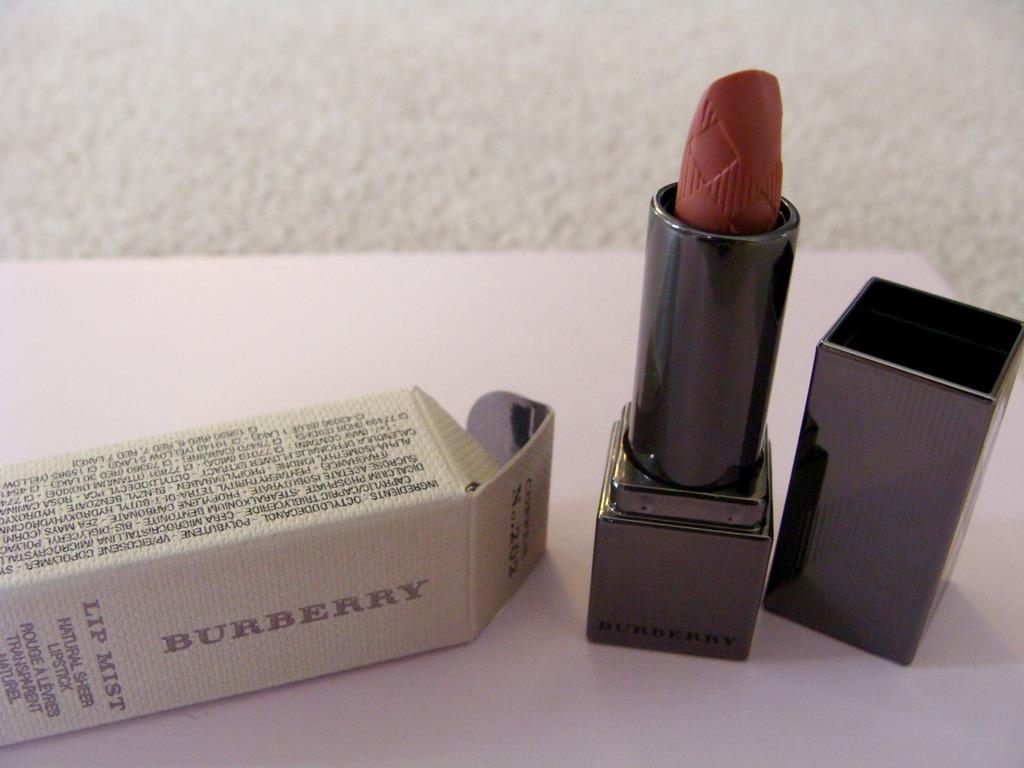What is the name of the lipstick?
Offer a very short reply. Burberry. What brand of lipstick?
Ensure brevity in your answer.  Burberry. 